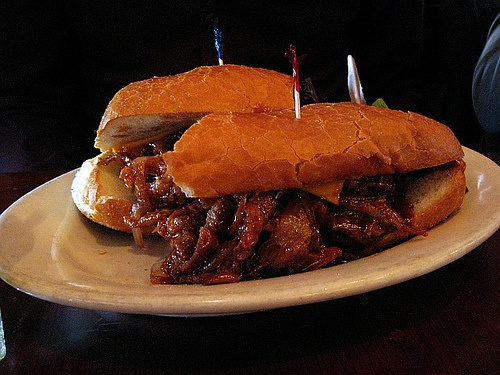Describe the objects in this image and their specific colors. I can see dining table in black, brown, maroon, tan, and gray tones, sandwich in black, maroon, and brown tones, sandwich in black, brown, red, and maroon tones, and people in black, gray, and darkblue tones in this image. 